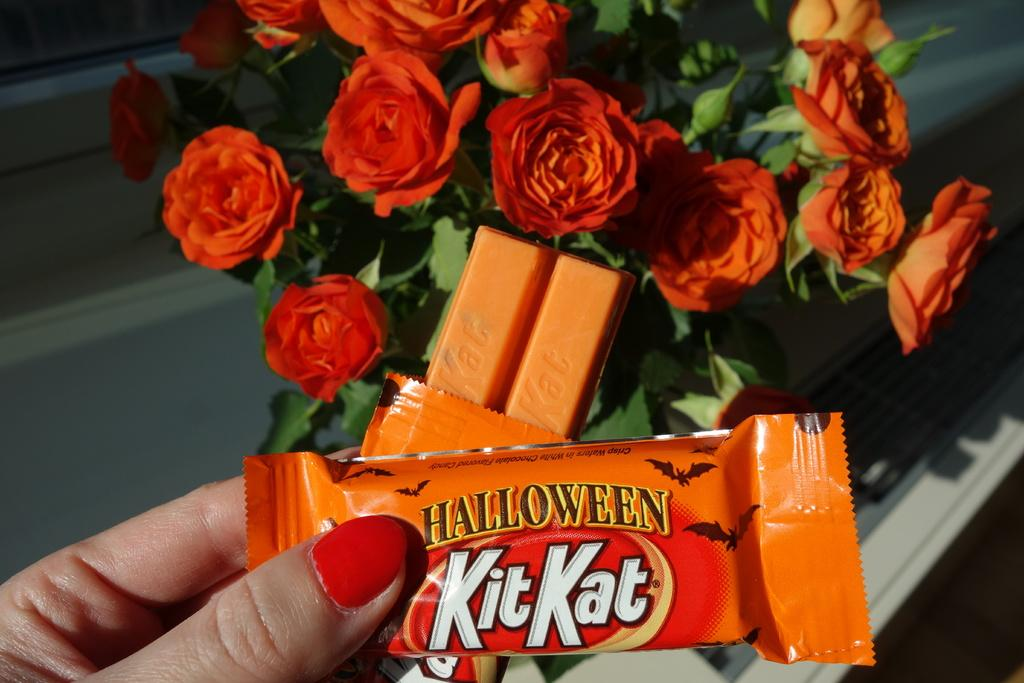What is the person holding in the image? The hand of a person is holding chocolates in the image. What type of plants can be seen in the image? There are flowers and leaves in the image. What type of engine can be seen in the image? There is no engine present in the image. How does the jelly contribute to the image? There is no jelly present in the image. 